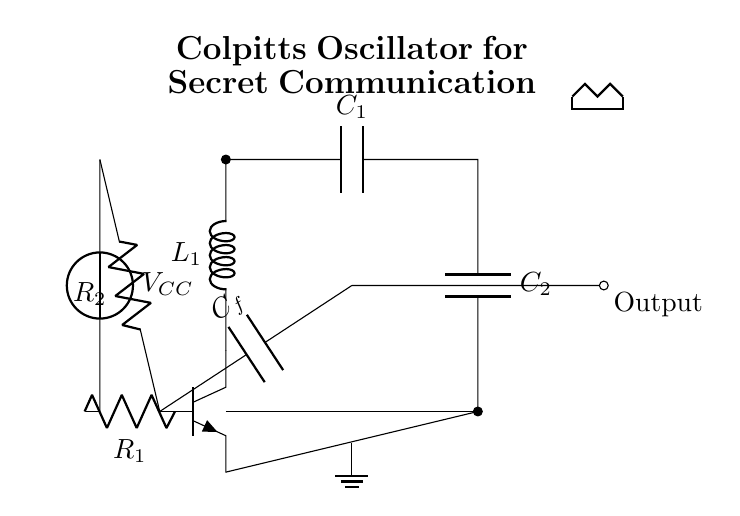What type of transistor is used in this circuit? The circuit uses an NPN transistor, which can be identified by the symbol in the diagram. The specific notation "npn" denotes that it is a bipolar junction transistor where the majority charge carriers are electrons.
Answer: NPN What does the output of the circuit connect to? The output is indicated by the connection at the right side of the circuit diagram, labeled as "Output." This line is connected to the capacitor in the LC tank circuit, and there is a short connection extending outwards, indicating output access.
Answer: Output What is the function of the capacitors C1 and C2 in the circuit? C1 and C2 form part of the LC tank circuit, which determines the oscillation frequency of the Colpitts oscillator. Their specific arrangement functions as a frequency-determining network.
Answer: Frequency determination Which component provides the necessary feedback for the oscillator? The feedback is provided by the capacitor labeled C_f, which connects from the base of the transistor and influences its switching behavior, enabling sustained oscillations.
Answer: C_f How are the resistors R1 and R2 positioned in relation to the transistor? R1 and R2 are connected to the base of the transistor; R1 goes to ground and R2 goes to the voltage supply (V_CC), which sets the biasing of the transistor for proper operation.
Answer: Biasing What is the primary role of the inductor L1 in this circuit? The inductor L1, in conjunction with capacitors C1 and C2, forms the resonant tank circuit that is crucial for generating the oscillation frequency. The inductor stores energy in its magnetic field, working with capacitors to create oscillation.
Answer: Oscillation generation What is the expected output signal type of this oscillator? The Colpitts oscillator is designed to generate an audio frequency waveform, typically a sine wave, suitable for modulating signals in communication applications.
Answer: Sine wave 